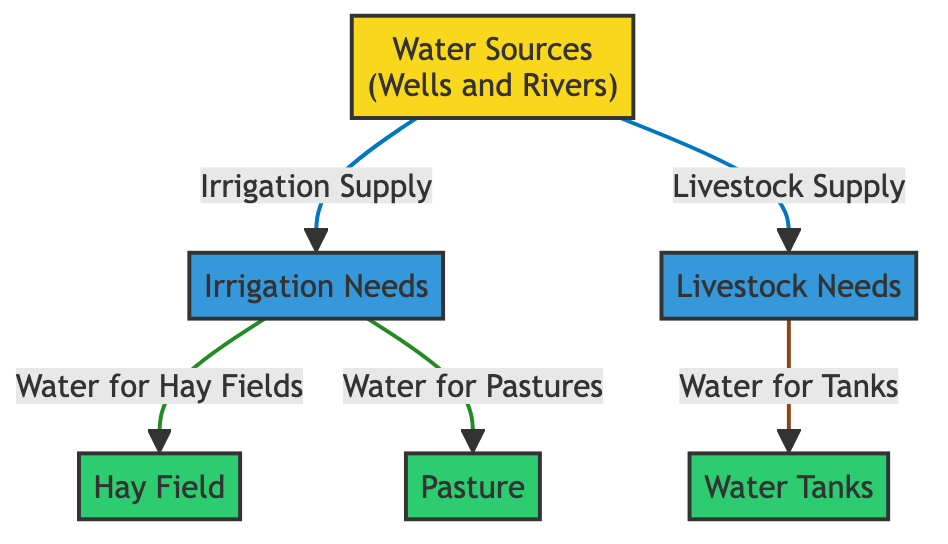What are the main water sources depicted in the diagram? The diagram shows "Wells" and "Rivers" as the main water sources, represented as a single entity labeled "Water Sources".
Answer: Water Sources How many destination nodes are there in the diagram? The diagram contains three destination nodes: "Hay Field", "Pasture", and "Water Tanks". This totals to 3.
Answer: 3 What supplies water for livestock needs? The water supply for livestock needs is provided directly from the "Water Sources", as indicated by the arrow labeled "Livestock Supply".
Answer: Water Sources What is the relationship between irrigation needs and hay fields? "Irrigation Needs" supplies water specifically for "Hay Fields", as shown by the arrow labeled "Water for Hay Fields".
Answer: Water for Hay Fields Which components are classified as needs in this diagram? The elements classified as needs are "Irrigation Needs" and "Livestock Needs", both highlighted in blue in the diagram.
Answer: Irrigation Needs, Livestock Needs How does water reach water tanks according to the diagram? Water reaches the "Water Tanks" from "Livestock Needs", indicated by the arrow labeled "Water for Tanks". Therefore, it flows from "Livestock Needs" to "Water Tanks".
Answer: Water for Tanks What color represents the sources in the diagram? The sources in the diagram are represented by a yellow fill color, indicated by the class definition "sourceClass".
Answer: Yellow Which elements get water directly from irrigation needs? The elements that receive water directly from "Irrigation Needs" are "Hay Field" and "Pasture", as both are connected by arrows labeled accordingly.
Answer: Hay Field, Pasture What is the primary function of the node labeled "Water Sources"? The primary function of "Water Sources" is to supply water for both irrigation and livestock needs as indicated by the arrows connecting it to both "Irrigation Needs" and "Livestock Needs".
Answer: Supply Water 